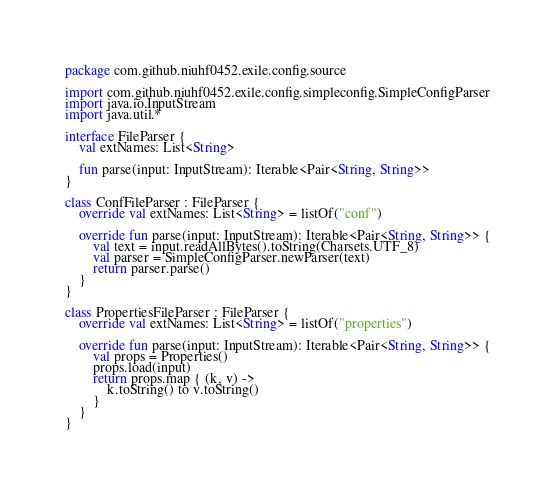<code> <loc_0><loc_0><loc_500><loc_500><_Kotlin_>package com.github.niuhf0452.exile.config.source

import com.github.niuhf0452.exile.config.simpleconfig.SimpleConfigParser
import java.io.InputStream
import java.util.*

interface FileParser {
    val extNames: List<String>

    fun parse(input: InputStream): Iterable<Pair<String, String>>
}

class ConfFileParser : FileParser {
    override val extNames: List<String> = listOf("conf")

    override fun parse(input: InputStream): Iterable<Pair<String, String>> {
        val text = input.readAllBytes().toString(Charsets.UTF_8)
        val parser = SimpleConfigParser.newParser(text)
        return parser.parse()
    }
}

class PropertiesFileParser : FileParser {
    override val extNames: List<String> = listOf("properties")

    override fun parse(input: InputStream): Iterable<Pair<String, String>> {
        val props = Properties()
        props.load(input)
        return props.map { (k, v) ->
            k.toString() to v.toString()
        }
    }
}</code> 